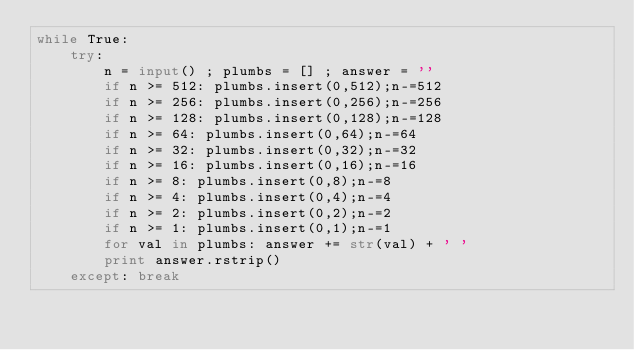Convert code to text. <code><loc_0><loc_0><loc_500><loc_500><_Python_>while True:
	try:
		n = input() ; plumbs = [] ; answer = ''
		if n >= 512: plumbs.insert(0,512);n-=512
		if n >= 256: plumbs.insert(0,256);n-=256
		if n >= 128: plumbs.insert(0,128);n-=128
		if n >= 64: plumbs.insert(0,64);n-=64
		if n >= 32: plumbs.insert(0,32);n-=32
		if n >= 16: plumbs.insert(0,16);n-=16
		if n >= 8: plumbs.insert(0,8);n-=8
		if n >= 4: plumbs.insert(0,4);n-=4
		if n >= 2: plumbs.insert(0,2);n-=2
		if n >= 1: plumbs.insert(0,1);n-=1
		for val in plumbs: answer += str(val) + ' '
		print answer.rstrip()
	except: break</code> 